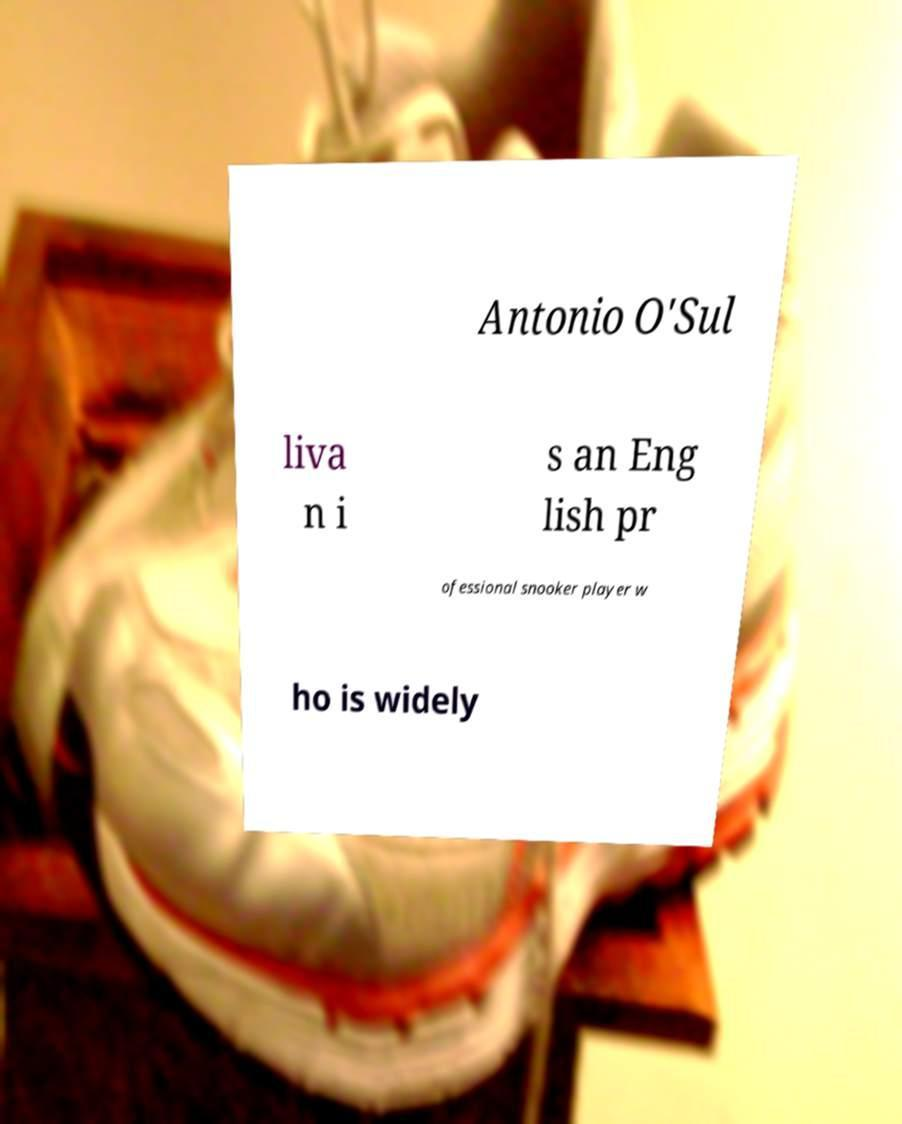What messages or text are displayed in this image? I need them in a readable, typed format. Antonio O'Sul liva n i s an Eng lish pr ofessional snooker player w ho is widely 